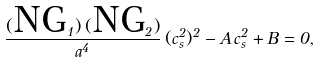Convert formula to latex. <formula><loc_0><loc_0><loc_500><loc_500>\frac { ( \text {NG} _ { 1 } ) \, ( \text {NG} _ { 2 } ) } { a ^ { 4 } } \, ( c _ { s } ^ { 2 } ) ^ { 2 } - A \, c _ { s } ^ { 2 } + B = 0 ,</formula> 